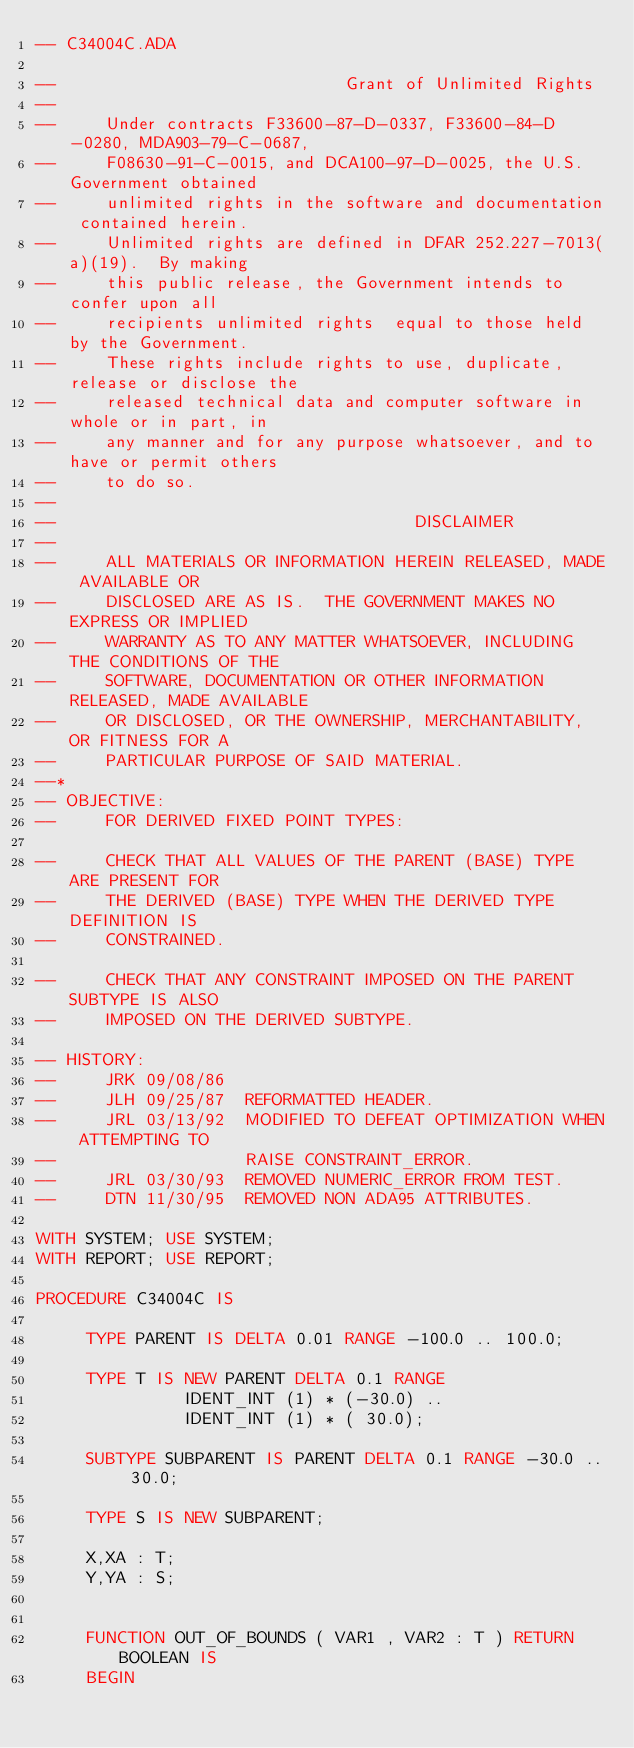Convert code to text. <code><loc_0><loc_0><loc_500><loc_500><_Ada_>-- C34004C.ADA

--                             Grant of Unlimited Rights
--
--     Under contracts F33600-87-D-0337, F33600-84-D-0280, MDA903-79-C-0687,
--     F08630-91-C-0015, and DCA100-97-D-0025, the U.S. Government obtained 
--     unlimited rights in the software and documentation contained herein.
--     Unlimited rights are defined in DFAR 252.227-7013(a)(19).  By making 
--     this public release, the Government intends to confer upon all 
--     recipients unlimited rights  equal to those held by the Government.  
--     These rights include rights to use, duplicate, release or disclose the 
--     released technical data and computer software in whole or in part, in 
--     any manner and for any purpose whatsoever, and to have or permit others 
--     to do so.
--
--                                    DISCLAIMER
--
--     ALL MATERIALS OR INFORMATION HEREIN RELEASED, MADE AVAILABLE OR
--     DISCLOSED ARE AS IS.  THE GOVERNMENT MAKES NO EXPRESS OR IMPLIED 
--     WARRANTY AS TO ANY MATTER WHATSOEVER, INCLUDING THE CONDITIONS OF THE
--     SOFTWARE, DOCUMENTATION OR OTHER INFORMATION RELEASED, MADE AVAILABLE 
--     OR DISCLOSED, OR THE OWNERSHIP, MERCHANTABILITY, OR FITNESS FOR A
--     PARTICULAR PURPOSE OF SAID MATERIAL.
--*
-- OBJECTIVE:
--     FOR DERIVED FIXED POINT TYPES:

--     CHECK THAT ALL VALUES OF THE PARENT (BASE) TYPE ARE PRESENT FOR
--     THE DERIVED (BASE) TYPE WHEN THE DERIVED TYPE DEFINITION IS
--     CONSTRAINED.

--     CHECK THAT ANY CONSTRAINT IMPOSED ON THE PARENT SUBTYPE IS ALSO
--     IMPOSED ON THE DERIVED SUBTYPE.

-- HISTORY:
--     JRK 09/08/86
--     JLH 09/25/87  REFORMATTED HEADER.
--     JRL 03/13/92  MODIFIED TO DEFEAT OPTIMIZATION WHEN ATTEMPTING TO
--                   RAISE CONSTRAINT_ERROR.
--     JRL 03/30/93  REMOVED NUMERIC_ERROR FROM TEST.
--     DTN 11/30/95  REMOVED NON ADA95 ATTRIBUTES.               

WITH SYSTEM; USE SYSTEM;
WITH REPORT; USE REPORT;

PROCEDURE C34004C IS

     TYPE PARENT IS DELTA 0.01 RANGE -100.0 .. 100.0;

     TYPE T IS NEW PARENT DELTA 0.1 RANGE
               IDENT_INT (1) * (-30.0) ..
               IDENT_INT (1) * ( 30.0);

     SUBTYPE SUBPARENT IS PARENT DELTA 0.1 RANGE -30.0 .. 30.0;

     TYPE S IS NEW SUBPARENT;

     X,XA : T;
     Y,YA : S;


     FUNCTION OUT_OF_BOUNDS ( VAR1 , VAR2 : T ) RETURN BOOLEAN IS
     BEGIN</code> 